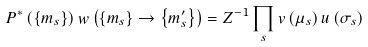Convert formula to latex. <formula><loc_0><loc_0><loc_500><loc_500>P ^ { \ast } \left ( \left \{ m _ { s } \right \} \right ) w \left ( \left \{ m _ { s } \right \} \rightarrow \left \{ m _ { s } ^ { \prime } \right \} \right ) = Z ^ { - 1 } \prod _ { s } v \left ( \mu _ { s } \right ) u \left ( \sigma _ { s } \right )</formula> 